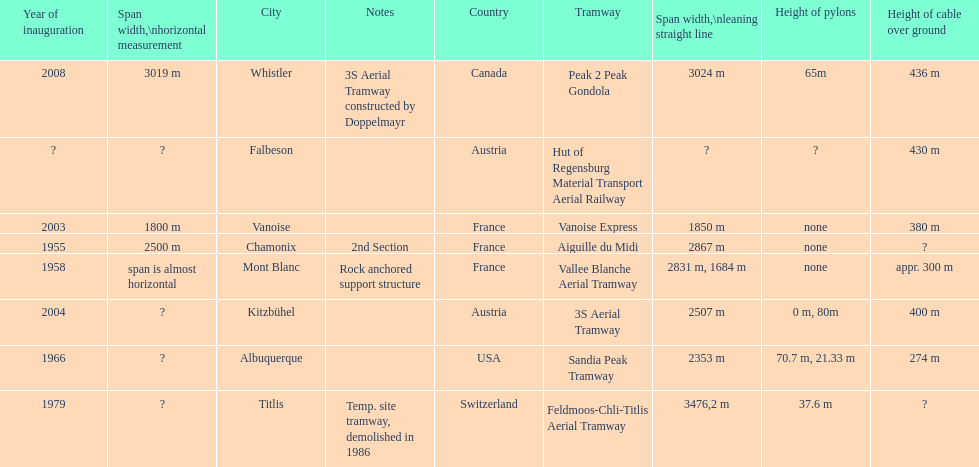Which tramway was inaugurated first, the 3s aerial tramway or the aiguille du midi? Aiguille du Midi. I'm looking to parse the entire table for insights. Could you assist me with that? {'header': ['Year of inauguration', 'Span width,\\nhorizontal measurement', 'City', 'Notes', 'Country', 'Tramway', 'Span\xa0width,\\nleaning straight line', 'Height of pylons', 'Height of cable over ground'], 'rows': [['2008', '3019 m', 'Whistler', '3S Aerial Tramway constructed by Doppelmayr', 'Canada', 'Peak 2 Peak Gondola', '3024 m', '65m', '436 m'], ['?', '?', 'Falbeson', '', 'Austria', 'Hut of Regensburg Material Transport Aerial Railway', '?', '?', '430 m'], ['2003', '1800 m', 'Vanoise', '', 'France', 'Vanoise Express', '1850 m', 'none', '380 m'], ['1955', '2500 m', 'Chamonix', '2nd Section', 'France', 'Aiguille du Midi', '2867 m', 'none', '?'], ['1958', 'span is almost horizontal', 'Mont Blanc', 'Rock anchored support structure', 'France', 'Vallee Blanche Aerial Tramway', '2831 m, 1684 m', 'none', 'appr. 300 m'], ['2004', '?', 'Kitzbühel', '', 'Austria', '3S Aerial Tramway', '2507 m', '0 m, 80m', '400 m'], ['1966', '?', 'Albuquerque', '', 'USA', 'Sandia Peak Tramway', '2353 m', '70.7 m, 21.33 m', '274 m'], ['1979', '?', 'Titlis', 'Temp. site tramway, demolished in 1986', 'Switzerland', 'Feldmoos-Chli-Titlis Aerial Tramway', '3476,2 m', '37.6 m', '?']]} 